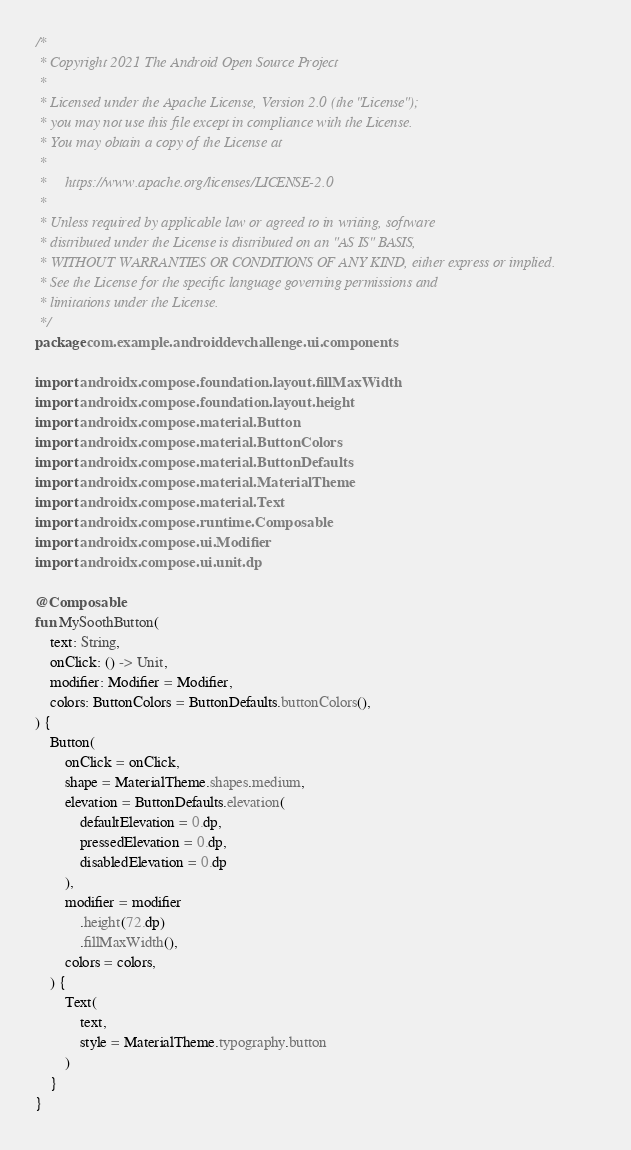Convert code to text. <code><loc_0><loc_0><loc_500><loc_500><_Kotlin_>/*
 * Copyright 2021 The Android Open Source Project
 *
 * Licensed under the Apache License, Version 2.0 (the "License");
 * you may not use this file except in compliance with the License.
 * You may obtain a copy of the License at
 *
 *     https://www.apache.org/licenses/LICENSE-2.0
 *
 * Unless required by applicable law or agreed to in writing, software
 * distributed under the License is distributed on an "AS IS" BASIS,
 * WITHOUT WARRANTIES OR CONDITIONS OF ANY KIND, either express or implied.
 * See the License for the specific language governing permissions and
 * limitations under the License.
 */
package com.example.androiddevchallenge.ui.components

import androidx.compose.foundation.layout.fillMaxWidth
import androidx.compose.foundation.layout.height
import androidx.compose.material.Button
import androidx.compose.material.ButtonColors
import androidx.compose.material.ButtonDefaults
import androidx.compose.material.MaterialTheme
import androidx.compose.material.Text
import androidx.compose.runtime.Composable
import androidx.compose.ui.Modifier
import androidx.compose.ui.unit.dp

@Composable
fun MySoothButton(
    text: String,
    onClick: () -> Unit,
    modifier: Modifier = Modifier,
    colors: ButtonColors = ButtonDefaults.buttonColors(),
) {
    Button(
        onClick = onClick,
        shape = MaterialTheme.shapes.medium,
        elevation = ButtonDefaults.elevation(
            defaultElevation = 0.dp,
            pressedElevation = 0.dp,
            disabledElevation = 0.dp
        ),
        modifier = modifier
            .height(72.dp)
            .fillMaxWidth(),
        colors = colors,
    ) {
        Text(
            text,
            style = MaterialTheme.typography.button
        )
    }
}
</code> 